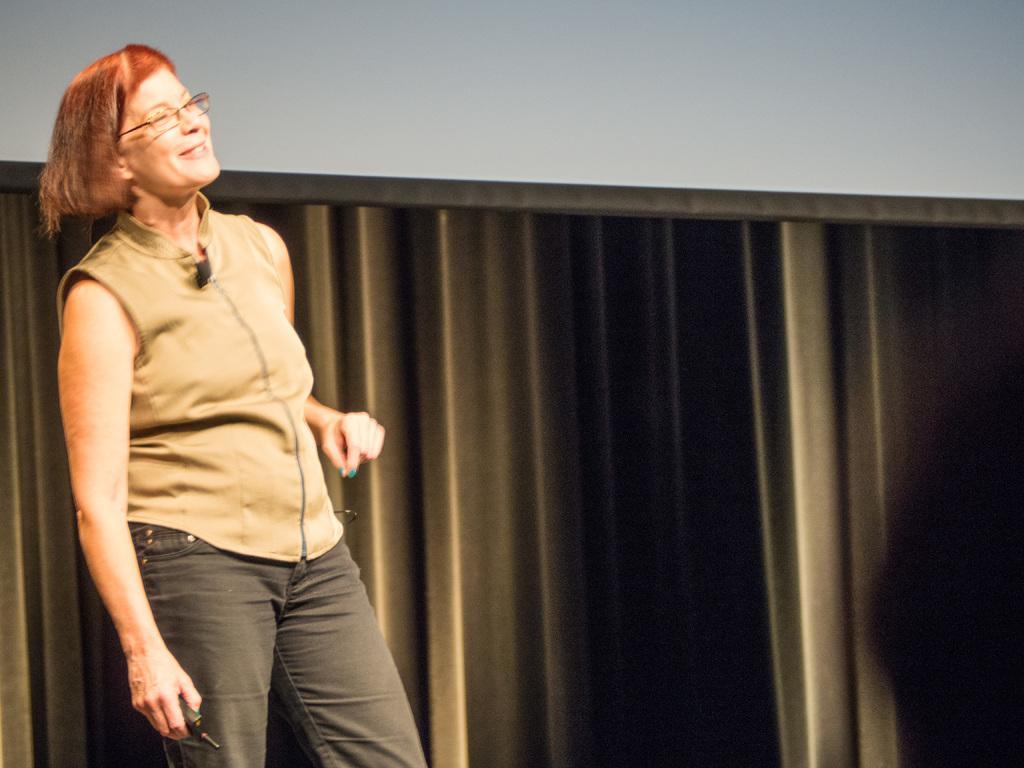How would you summarize this image in a sentence or two? This is the woman standing and smiling. She is holding a black color object in her hand. She wore spectacles, top and trouser. This looks like a curtain cloth hanging. 